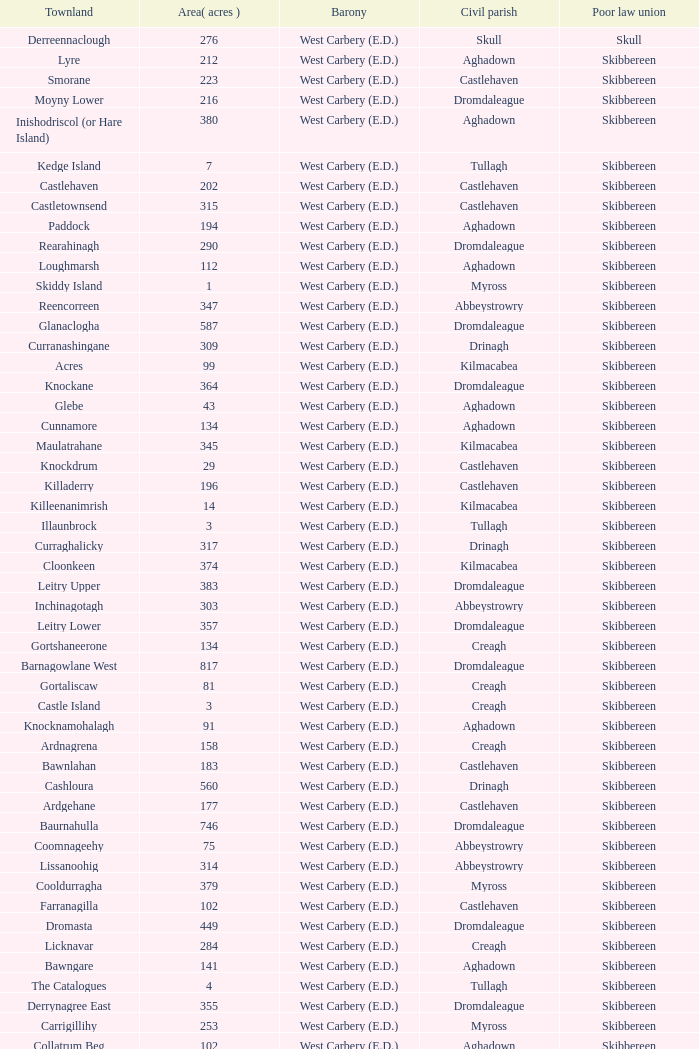What are the civil parishes of the Loughmarsh townland? Aghadown. 